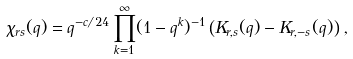<formula> <loc_0><loc_0><loc_500><loc_500>\chi _ { r s } ( q ) = q ^ { - c / 2 4 } \prod _ { k = 1 } ^ { \infty } ( 1 - q ^ { k } ) ^ { - 1 } \left ( K _ { r , s } ( q ) - K _ { r , - s } ( q ) \right ) \, ,</formula> 